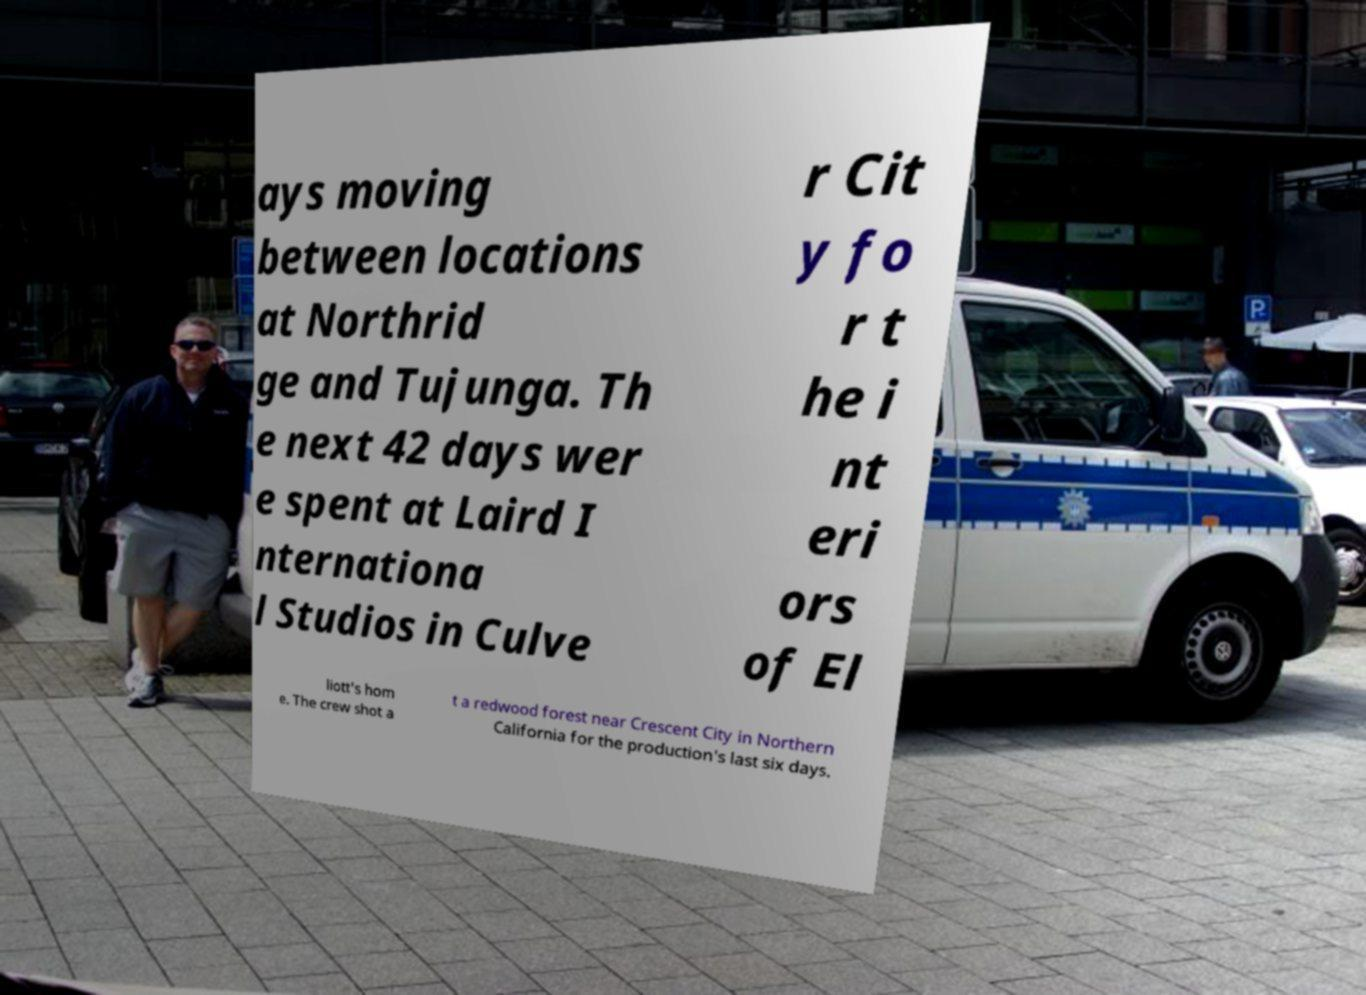Can you read and provide the text displayed in the image?This photo seems to have some interesting text. Can you extract and type it out for me? ays moving between locations at Northrid ge and Tujunga. Th e next 42 days wer e spent at Laird I nternationa l Studios in Culve r Cit y fo r t he i nt eri ors of El liott's hom e. The crew shot a t a redwood forest near Crescent City in Northern California for the production's last six days. 